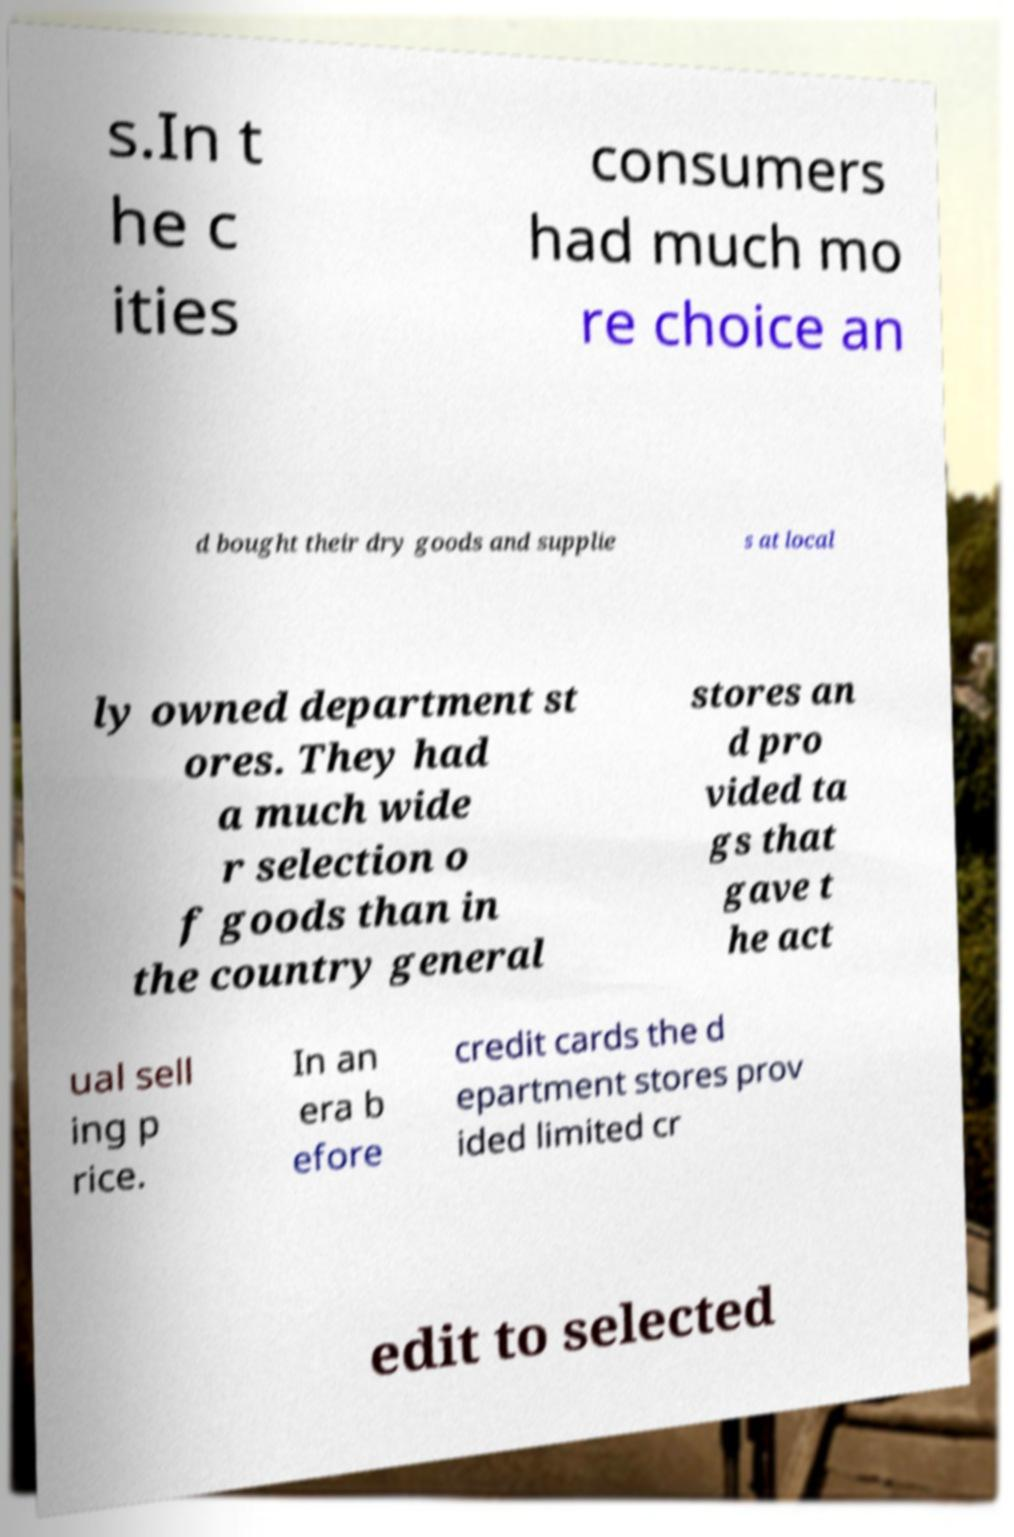Can you read and provide the text displayed in the image?This photo seems to have some interesting text. Can you extract and type it out for me? s.In t he c ities consumers had much mo re choice an d bought their dry goods and supplie s at local ly owned department st ores. They had a much wide r selection o f goods than in the country general stores an d pro vided ta gs that gave t he act ual sell ing p rice. In an era b efore credit cards the d epartment stores prov ided limited cr edit to selected 